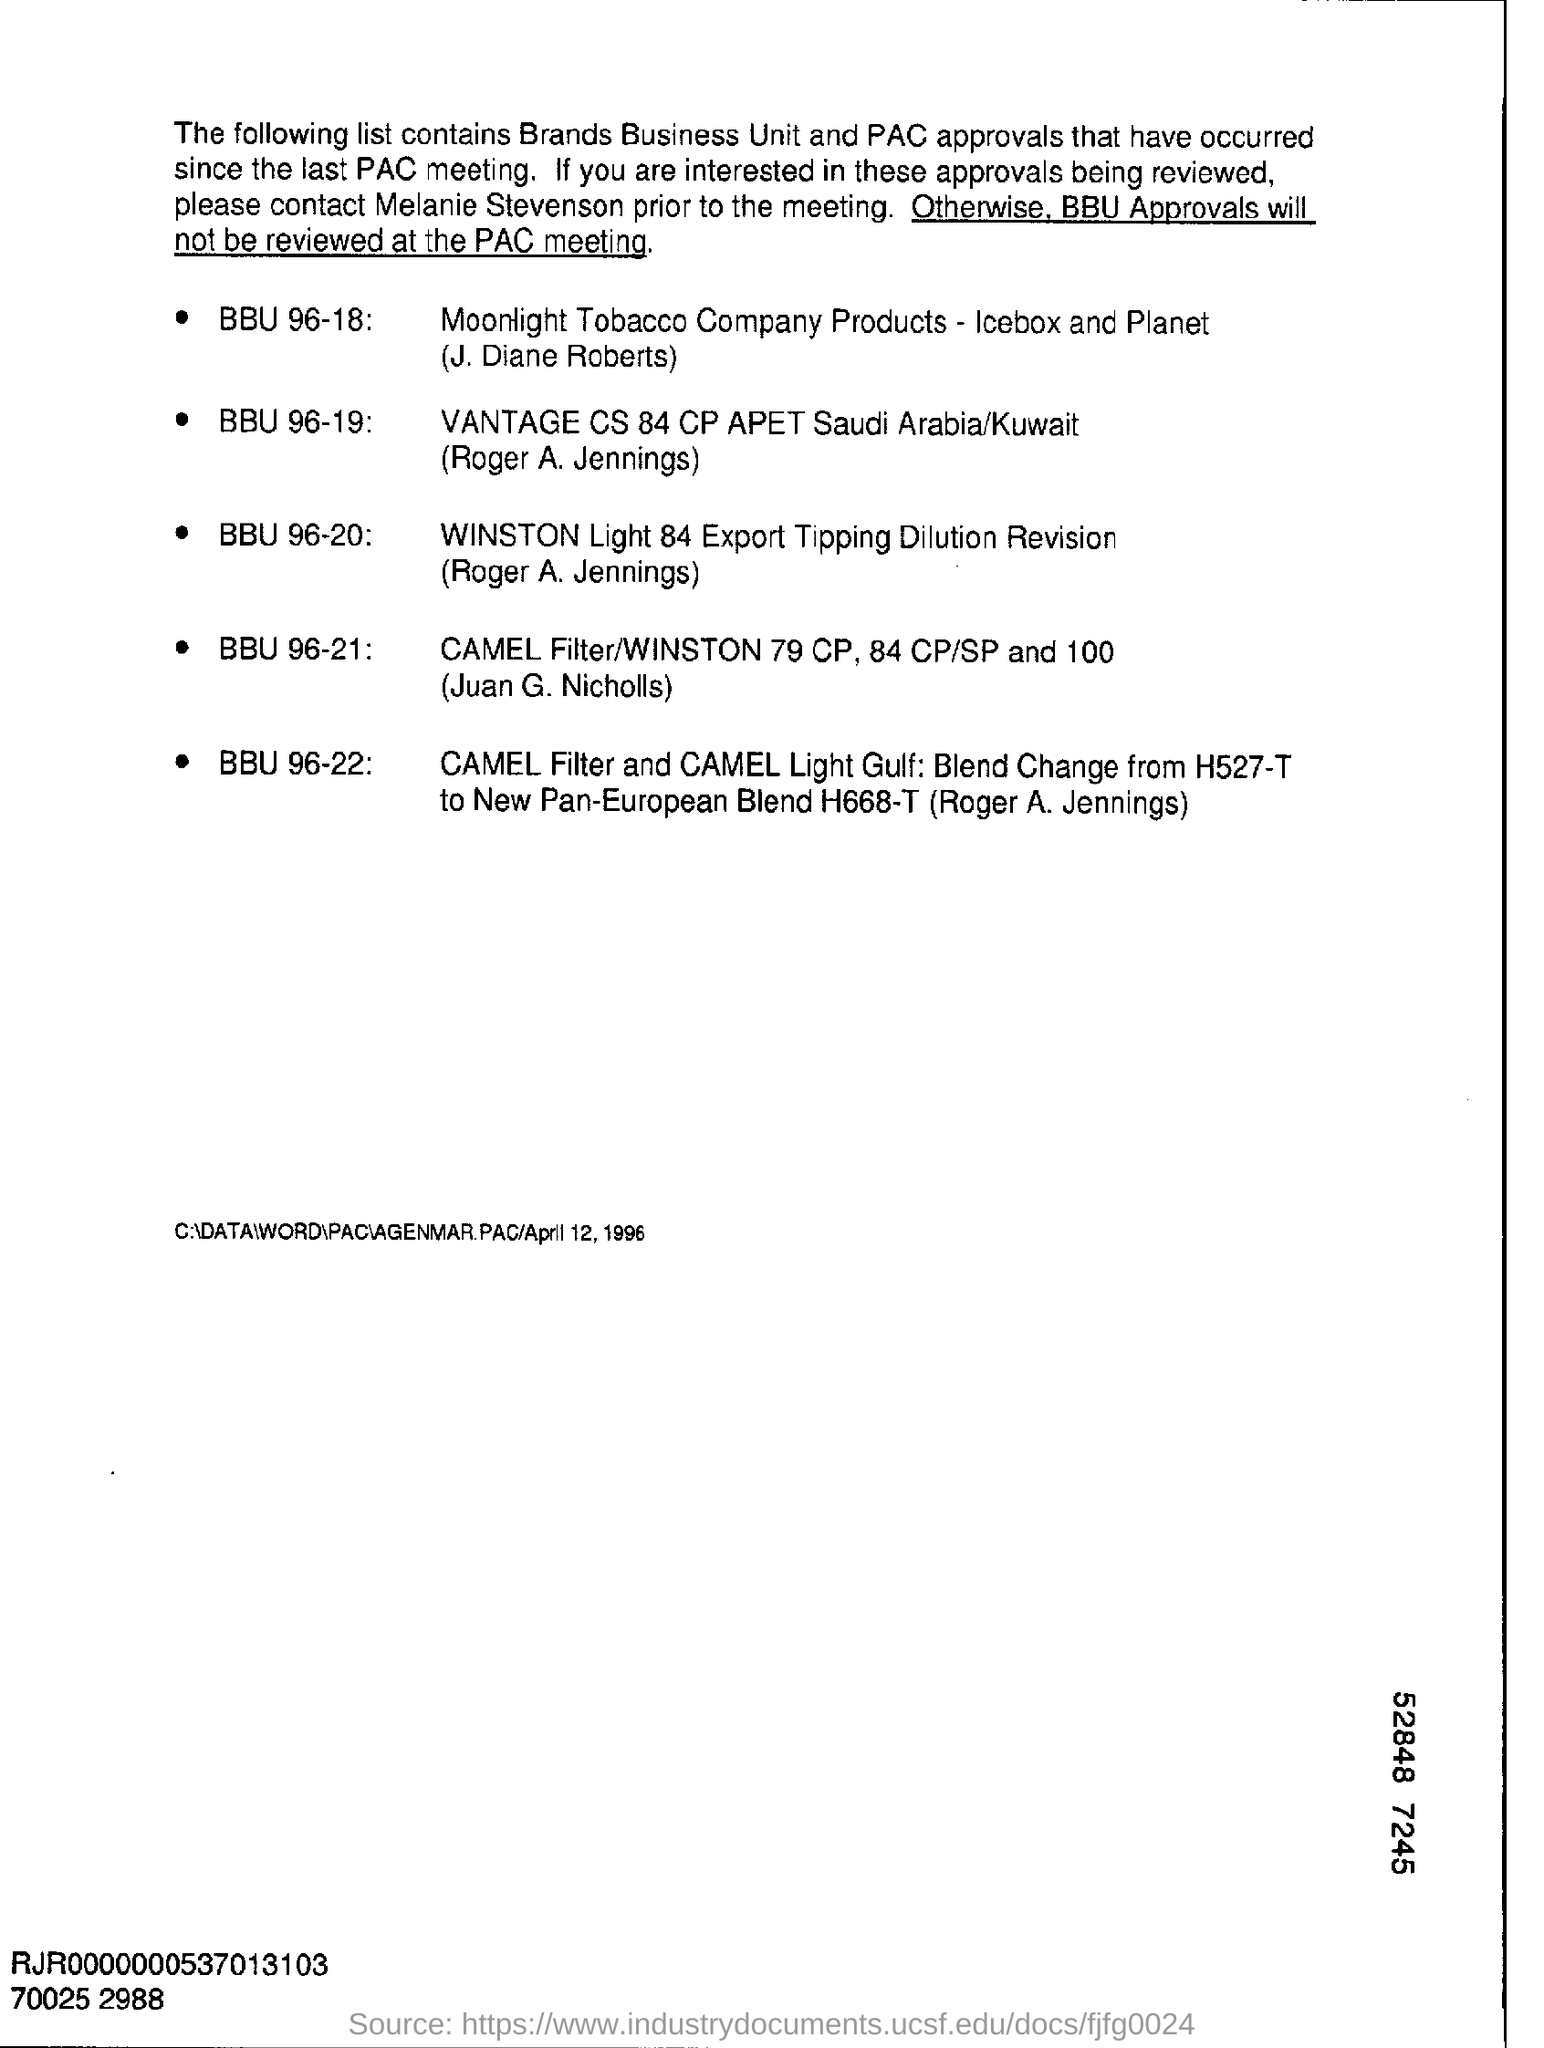What does the list contain?
Provide a succinct answer. Brands Business Unit and PAC approvals. 